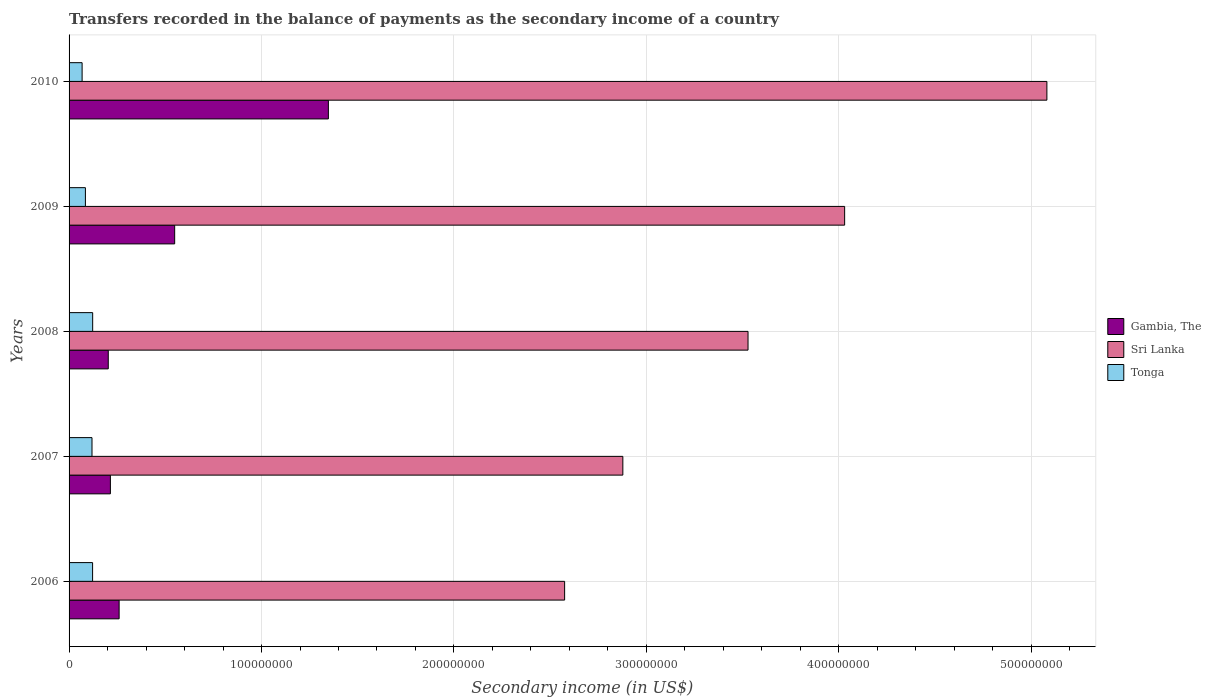How many different coloured bars are there?
Your answer should be very brief. 3. Are the number of bars per tick equal to the number of legend labels?
Offer a terse response. Yes. How many bars are there on the 3rd tick from the top?
Your answer should be very brief. 3. How many bars are there on the 1st tick from the bottom?
Your answer should be very brief. 3. What is the label of the 5th group of bars from the top?
Your response must be concise. 2006. In how many cases, is the number of bars for a given year not equal to the number of legend labels?
Your answer should be compact. 0. What is the secondary income of in Tonga in 2009?
Provide a succinct answer. 8.49e+06. Across all years, what is the maximum secondary income of in Tonga?
Offer a terse response. 1.23e+07. Across all years, what is the minimum secondary income of in Gambia, The?
Offer a terse response. 2.04e+07. In which year was the secondary income of in Tonga maximum?
Provide a short and direct response. 2008. In which year was the secondary income of in Gambia, The minimum?
Offer a terse response. 2008. What is the total secondary income of in Sri Lanka in the graph?
Provide a short and direct response. 1.81e+09. What is the difference between the secondary income of in Sri Lanka in 2009 and that in 2010?
Make the answer very short. -1.05e+08. What is the difference between the secondary income of in Gambia, The in 2006 and the secondary income of in Tonga in 2008?
Your answer should be very brief. 1.37e+07. What is the average secondary income of in Gambia, The per year?
Your answer should be compact. 5.15e+07. In the year 2006, what is the difference between the secondary income of in Tonga and secondary income of in Sri Lanka?
Provide a short and direct response. -2.45e+08. What is the ratio of the secondary income of in Tonga in 2008 to that in 2010?
Provide a succinct answer. 1.81. What is the difference between the highest and the second highest secondary income of in Sri Lanka?
Keep it short and to the point. 1.05e+08. What is the difference between the highest and the lowest secondary income of in Sri Lanka?
Keep it short and to the point. 2.51e+08. In how many years, is the secondary income of in Sri Lanka greater than the average secondary income of in Sri Lanka taken over all years?
Your answer should be compact. 2. Is the sum of the secondary income of in Gambia, The in 2007 and 2010 greater than the maximum secondary income of in Sri Lanka across all years?
Your answer should be compact. No. What does the 2nd bar from the top in 2008 represents?
Offer a terse response. Sri Lanka. What does the 3rd bar from the bottom in 2009 represents?
Provide a succinct answer. Tonga. Is it the case that in every year, the sum of the secondary income of in Gambia, The and secondary income of in Sri Lanka is greater than the secondary income of in Tonga?
Your answer should be very brief. Yes. Are all the bars in the graph horizontal?
Offer a very short reply. Yes. Where does the legend appear in the graph?
Offer a terse response. Center right. What is the title of the graph?
Your answer should be compact. Transfers recorded in the balance of payments as the secondary income of a country. What is the label or title of the X-axis?
Provide a succinct answer. Secondary income (in US$). What is the Secondary income (in US$) in Gambia, The in 2006?
Your response must be concise. 2.60e+07. What is the Secondary income (in US$) in Sri Lanka in 2006?
Your response must be concise. 2.58e+08. What is the Secondary income (in US$) in Tonga in 2006?
Make the answer very short. 1.22e+07. What is the Secondary income (in US$) in Gambia, The in 2007?
Give a very brief answer. 2.15e+07. What is the Secondary income (in US$) of Sri Lanka in 2007?
Keep it short and to the point. 2.88e+08. What is the Secondary income (in US$) in Tonga in 2007?
Your answer should be compact. 1.19e+07. What is the Secondary income (in US$) of Gambia, The in 2008?
Make the answer very short. 2.04e+07. What is the Secondary income (in US$) of Sri Lanka in 2008?
Ensure brevity in your answer.  3.53e+08. What is the Secondary income (in US$) of Tonga in 2008?
Offer a very short reply. 1.23e+07. What is the Secondary income (in US$) of Gambia, The in 2009?
Your answer should be very brief. 5.49e+07. What is the Secondary income (in US$) of Sri Lanka in 2009?
Your response must be concise. 4.03e+08. What is the Secondary income (in US$) of Tonga in 2009?
Give a very brief answer. 8.49e+06. What is the Secondary income (in US$) of Gambia, The in 2010?
Ensure brevity in your answer.  1.35e+08. What is the Secondary income (in US$) of Sri Lanka in 2010?
Offer a very short reply. 5.08e+08. What is the Secondary income (in US$) of Tonga in 2010?
Your answer should be very brief. 6.77e+06. Across all years, what is the maximum Secondary income (in US$) of Gambia, The?
Ensure brevity in your answer.  1.35e+08. Across all years, what is the maximum Secondary income (in US$) in Sri Lanka?
Give a very brief answer. 5.08e+08. Across all years, what is the maximum Secondary income (in US$) of Tonga?
Provide a succinct answer. 1.23e+07. Across all years, what is the minimum Secondary income (in US$) of Gambia, The?
Offer a terse response. 2.04e+07. Across all years, what is the minimum Secondary income (in US$) in Sri Lanka?
Your response must be concise. 2.58e+08. Across all years, what is the minimum Secondary income (in US$) of Tonga?
Your answer should be compact. 6.77e+06. What is the total Secondary income (in US$) in Gambia, The in the graph?
Keep it short and to the point. 2.57e+08. What is the total Secondary income (in US$) in Sri Lanka in the graph?
Your answer should be very brief. 1.81e+09. What is the total Secondary income (in US$) in Tonga in the graph?
Keep it short and to the point. 5.17e+07. What is the difference between the Secondary income (in US$) in Gambia, The in 2006 and that in 2007?
Offer a terse response. 4.54e+06. What is the difference between the Secondary income (in US$) of Sri Lanka in 2006 and that in 2007?
Make the answer very short. -3.02e+07. What is the difference between the Secondary income (in US$) of Tonga in 2006 and that in 2007?
Keep it short and to the point. 3.08e+05. What is the difference between the Secondary income (in US$) in Gambia, The in 2006 and that in 2008?
Make the answer very short. 5.64e+06. What is the difference between the Secondary income (in US$) of Sri Lanka in 2006 and that in 2008?
Keep it short and to the point. -9.53e+07. What is the difference between the Secondary income (in US$) of Tonga in 2006 and that in 2008?
Give a very brief answer. -4.22e+04. What is the difference between the Secondary income (in US$) of Gambia, The in 2006 and that in 2009?
Ensure brevity in your answer.  -2.89e+07. What is the difference between the Secondary income (in US$) of Sri Lanka in 2006 and that in 2009?
Your answer should be compact. -1.46e+08. What is the difference between the Secondary income (in US$) in Tonga in 2006 and that in 2009?
Keep it short and to the point. 3.73e+06. What is the difference between the Secondary income (in US$) of Gambia, The in 2006 and that in 2010?
Keep it short and to the point. -1.09e+08. What is the difference between the Secondary income (in US$) of Sri Lanka in 2006 and that in 2010?
Your response must be concise. -2.51e+08. What is the difference between the Secondary income (in US$) in Tonga in 2006 and that in 2010?
Offer a very short reply. 5.45e+06. What is the difference between the Secondary income (in US$) of Gambia, The in 2007 and that in 2008?
Provide a short and direct response. 1.10e+06. What is the difference between the Secondary income (in US$) in Sri Lanka in 2007 and that in 2008?
Provide a succinct answer. -6.50e+07. What is the difference between the Secondary income (in US$) in Tonga in 2007 and that in 2008?
Offer a very short reply. -3.50e+05. What is the difference between the Secondary income (in US$) of Gambia, The in 2007 and that in 2009?
Provide a succinct answer. -3.34e+07. What is the difference between the Secondary income (in US$) of Sri Lanka in 2007 and that in 2009?
Offer a terse response. -1.15e+08. What is the difference between the Secondary income (in US$) in Tonga in 2007 and that in 2009?
Provide a succinct answer. 3.42e+06. What is the difference between the Secondary income (in US$) in Gambia, The in 2007 and that in 2010?
Your response must be concise. -1.13e+08. What is the difference between the Secondary income (in US$) in Sri Lanka in 2007 and that in 2010?
Offer a terse response. -2.20e+08. What is the difference between the Secondary income (in US$) of Tonga in 2007 and that in 2010?
Your answer should be compact. 5.14e+06. What is the difference between the Secondary income (in US$) in Gambia, The in 2008 and that in 2009?
Your answer should be very brief. -3.45e+07. What is the difference between the Secondary income (in US$) of Sri Lanka in 2008 and that in 2009?
Keep it short and to the point. -5.02e+07. What is the difference between the Secondary income (in US$) in Tonga in 2008 and that in 2009?
Give a very brief answer. 3.77e+06. What is the difference between the Secondary income (in US$) of Gambia, The in 2008 and that in 2010?
Your response must be concise. -1.14e+08. What is the difference between the Secondary income (in US$) of Sri Lanka in 2008 and that in 2010?
Offer a very short reply. -1.55e+08. What is the difference between the Secondary income (in US$) in Tonga in 2008 and that in 2010?
Keep it short and to the point. 5.49e+06. What is the difference between the Secondary income (in US$) in Gambia, The in 2009 and that in 2010?
Provide a succinct answer. -7.99e+07. What is the difference between the Secondary income (in US$) of Sri Lanka in 2009 and that in 2010?
Keep it short and to the point. -1.05e+08. What is the difference between the Secondary income (in US$) of Tonga in 2009 and that in 2010?
Offer a very short reply. 1.72e+06. What is the difference between the Secondary income (in US$) of Gambia, The in 2006 and the Secondary income (in US$) of Sri Lanka in 2007?
Your response must be concise. -2.62e+08. What is the difference between the Secondary income (in US$) of Gambia, The in 2006 and the Secondary income (in US$) of Tonga in 2007?
Your response must be concise. 1.41e+07. What is the difference between the Secondary income (in US$) of Sri Lanka in 2006 and the Secondary income (in US$) of Tonga in 2007?
Keep it short and to the point. 2.46e+08. What is the difference between the Secondary income (in US$) in Gambia, The in 2006 and the Secondary income (in US$) in Sri Lanka in 2008?
Ensure brevity in your answer.  -3.27e+08. What is the difference between the Secondary income (in US$) of Gambia, The in 2006 and the Secondary income (in US$) of Tonga in 2008?
Keep it short and to the point. 1.37e+07. What is the difference between the Secondary income (in US$) of Sri Lanka in 2006 and the Secondary income (in US$) of Tonga in 2008?
Your response must be concise. 2.45e+08. What is the difference between the Secondary income (in US$) in Gambia, The in 2006 and the Secondary income (in US$) in Sri Lanka in 2009?
Your response must be concise. -3.77e+08. What is the difference between the Secondary income (in US$) of Gambia, The in 2006 and the Secondary income (in US$) of Tonga in 2009?
Your answer should be very brief. 1.75e+07. What is the difference between the Secondary income (in US$) of Sri Lanka in 2006 and the Secondary income (in US$) of Tonga in 2009?
Give a very brief answer. 2.49e+08. What is the difference between the Secondary income (in US$) of Gambia, The in 2006 and the Secondary income (in US$) of Sri Lanka in 2010?
Ensure brevity in your answer.  -4.82e+08. What is the difference between the Secondary income (in US$) of Gambia, The in 2006 and the Secondary income (in US$) of Tonga in 2010?
Make the answer very short. 1.92e+07. What is the difference between the Secondary income (in US$) in Sri Lanka in 2006 and the Secondary income (in US$) in Tonga in 2010?
Ensure brevity in your answer.  2.51e+08. What is the difference between the Secondary income (in US$) in Gambia, The in 2007 and the Secondary income (in US$) in Sri Lanka in 2008?
Make the answer very short. -3.31e+08. What is the difference between the Secondary income (in US$) of Gambia, The in 2007 and the Secondary income (in US$) of Tonga in 2008?
Your answer should be compact. 9.21e+06. What is the difference between the Secondary income (in US$) in Sri Lanka in 2007 and the Secondary income (in US$) in Tonga in 2008?
Offer a very short reply. 2.75e+08. What is the difference between the Secondary income (in US$) of Gambia, The in 2007 and the Secondary income (in US$) of Sri Lanka in 2009?
Offer a very short reply. -3.82e+08. What is the difference between the Secondary income (in US$) in Gambia, The in 2007 and the Secondary income (in US$) in Tonga in 2009?
Your response must be concise. 1.30e+07. What is the difference between the Secondary income (in US$) in Sri Lanka in 2007 and the Secondary income (in US$) in Tonga in 2009?
Give a very brief answer. 2.79e+08. What is the difference between the Secondary income (in US$) of Gambia, The in 2007 and the Secondary income (in US$) of Sri Lanka in 2010?
Provide a succinct answer. -4.87e+08. What is the difference between the Secondary income (in US$) of Gambia, The in 2007 and the Secondary income (in US$) of Tonga in 2010?
Provide a succinct answer. 1.47e+07. What is the difference between the Secondary income (in US$) of Sri Lanka in 2007 and the Secondary income (in US$) of Tonga in 2010?
Your answer should be very brief. 2.81e+08. What is the difference between the Secondary income (in US$) of Gambia, The in 2008 and the Secondary income (in US$) of Sri Lanka in 2009?
Ensure brevity in your answer.  -3.83e+08. What is the difference between the Secondary income (in US$) of Gambia, The in 2008 and the Secondary income (in US$) of Tonga in 2009?
Make the answer very short. 1.19e+07. What is the difference between the Secondary income (in US$) of Sri Lanka in 2008 and the Secondary income (in US$) of Tonga in 2009?
Keep it short and to the point. 3.44e+08. What is the difference between the Secondary income (in US$) in Gambia, The in 2008 and the Secondary income (in US$) in Sri Lanka in 2010?
Make the answer very short. -4.88e+08. What is the difference between the Secondary income (in US$) in Gambia, The in 2008 and the Secondary income (in US$) in Tonga in 2010?
Keep it short and to the point. 1.36e+07. What is the difference between the Secondary income (in US$) of Sri Lanka in 2008 and the Secondary income (in US$) of Tonga in 2010?
Offer a terse response. 3.46e+08. What is the difference between the Secondary income (in US$) in Gambia, The in 2009 and the Secondary income (in US$) in Sri Lanka in 2010?
Offer a terse response. -4.53e+08. What is the difference between the Secondary income (in US$) in Gambia, The in 2009 and the Secondary income (in US$) in Tonga in 2010?
Make the answer very short. 4.81e+07. What is the difference between the Secondary income (in US$) in Sri Lanka in 2009 and the Secondary income (in US$) in Tonga in 2010?
Offer a very short reply. 3.96e+08. What is the average Secondary income (in US$) of Gambia, The per year?
Your response must be concise. 5.15e+07. What is the average Secondary income (in US$) in Sri Lanka per year?
Provide a succinct answer. 3.62e+08. What is the average Secondary income (in US$) of Tonga per year?
Provide a succinct answer. 1.03e+07. In the year 2006, what is the difference between the Secondary income (in US$) in Gambia, The and Secondary income (in US$) in Sri Lanka?
Give a very brief answer. -2.31e+08. In the year 2006, what is the difference between the Secondary income (in US$) in Gambia, The and Secondary income (in US$) in Tonga?
Your response must be concise. 1.38e+07. In the year 2006, what is the difference between the Secondary income (in US$) in Sri Lanka and Secondary income (in US$) in Tonga?
Ensure brevity in your answer.  2.45e+08. In the year 2007, what is the difference between the Secondary income (in US$) of Gambia, The and Secondary income (in US$) of Sri Lanka?
Offer a very short reply. -2.66e+08. In the year 2007, what is the difference between the Secondary income (in US$) of Gambia, The and Secondary income (in US$) of Tonga?
Provide a succinct answer. 9.56e+06. In the year 2007, what is the difference between the Secondary income (in US$) in Sri Lanka and Secondary income (in US$) in Tonga?
Your response must be concise. 2.76e+08. In the year 2008, what is the difference between the Secondary income (in US$) in Gambia, The and Secondary income (in US$) in Sri Lanka?
Give a very brief answer. -3.32e+08. In the year 2008, what is the difference between the Secondary income (in US$) in Gambia, The and Secondary income (in US$) in Tonga?
Provide a short and direct response. 8.11e+06. In the year 2008, what is the difference between the Secondary income (in US$) of Sri Lanka and Secondary income (in US$) of Tonga?
Offer a very short reply. 3.41e+08. In the year 2009, what is the difference between the Secondary income (in US$) of Gambia, The and Secondary income (in US$) of Sri Lanka?
Your answer should be very brief. -3.48e+08. In the year 2009, what is the difference between the Secondary income (in US$) of Gambia, The and Secondary income (in US$) of Tonga?
Offer a terse response. 4.64e+07. In the year 2009, what is the difference between the Secondary income (in US$) of Sri Lanka and Secondary income (in US$) of Tonga?
Give a very brief answer. 3.95e+08. In the year 2010, what is the difference between the Secondary income (in US$) of Gambia, The and Secondary income (in US$) of Sri Lanka?
Keep it short and to the point. -3.73e+08. In the year 2010, what is the difference between the Secondary income (in US$) in Gambia, The and Secondary income (in US$) in Tonga?
Give a very brief answer. 1.28e+08. In the year 2010, what is the difference between the Secondary income (in US$) of Sri Lanka and Secondary income (in US$) of Tonga?
Provide a short and direct response. 5.01e+08. What is the ratio of the Secondary income (in US$) of Gambia, The in 2006 to that in 2007?
Your answer should be compact. 1.21. What is the ratio of the Secondary income (in US$) in Sri Lanka in 2006 to that in 2007?
Provide a short and direct response. 0.89. What is the ratio of the Secondary income (in US$) of Tonga in 2006 to that in 2007?
Offer a terse response. 1.03. What is the ratio of the Secondary income (in US$) in Gambia, The in 2006 to that in 2008?
Offer a very short reply. 1.28. What is the ratio of the Secondary income (in US$) in Sri Lanka in 2006 to that in 2008?
Offer a very short reply. 0.73. What is the ratio of the Secondary income (in US$) of Gambia, The in 2006 to that in 2009?
Give a very brief answer. 0.47. What is the ratio of the Secondary income (in US$) of Sri Lanka in 2006 to that in 2009?
Make the answer very short. 0.64. What is the ratio of the Secondary income (in US$) of Tonga in 2006 to that in 2009?
Make the answer very short. 1.44. What is the ratio of the Secondary income (in US$) in Gambia, The in 2006 to that in 2010?
Offer a very short reply. 0.19. What is the ratio of the Secondary income (in US$) of Sri Lanka in 2006 to that in 2010?
Provide a short and direct response. 0.51. What is the ratio of the Secondary income (in US$) in Tonga in 2006 to that in 2010?
Provide a succinct answer. 1.8. What is the ratio of the Secondary income (in US$) in Gambia, The in 2007 to that in 2008?
Your answer should be very brief. 1.05. What is the ratio of the Secondary income (in US$) in Sri Lanka in 2007 to that in 2008?
Make the answer very short. 0.82. What is the ratio of the Secondary income (in US$) of Tonga in 2007 to that in 2008?
Keep it short and to the point. 0.97. What is the ratio of the Secondary income (in US$) of Gambia, The in 2007 to that in 2009?
Provide a short and direct response. 0.39. What is the ratio of the Secondary income (in US$) in Sri Lanka in 2007 to that in 2009?
Offer a terse response. 0.71. What is the ratio of the Secondary income (in US$) of Tonga in 2007 to that in 2009?
Your answer should be very brief. 1.4. What is the ratio of the Secondary income (in US$) of Gambia, The in 2007 to that in 2010?
Your answer should be very brief. 0.16. What is the ratio of the Secondary income (in US$) in Sri Lanka in 2007 to that in 2010?
Provide a short and direct response. 0.57. What is the ratio of the Secondary income (in US$) of Tonga in 2007 to that in 2010?
Your answer should be very brief. 1.76. What is the ratio of the Secondary income (in US$) in Gambia, The in 2008 to that in 2009?
Give a very brief answer. 0.37. What is the ratio of the Secondary income (in US$) of Sri Lanka in 2008 to that in 2009?
Ensure brevity in your answer.  0.88. What is the ratio of the Secondary income (in US$) of Tonga in 2008 to that in 2009?
Ensure brevity in your answer.  1.44. What is the ratio of the Secondary income (in US$) in Gambia, The in 2008 to that in 2010?
Provide a succinct answer. 0.15. What is the ratio of the Secondary income (in US$) of Sri Lanka in 2008 to that in 2010?
Offer a very short reply. 0.69. What is the ratio of the Secondary income (in US$) in Tonga in 2008 to that in 2010?
Your response must be concise. 1.81. What is the ratio of the Secondary income (in US$) of Gambia, The in 2009 to that in 2010?
Offer a terse response. 0.41. What is the ratio of the Secondary income (in US$) in Sri Lanka in 2009 to that in 2010?
Your answer should be compact. 0.79. What is the ratio of the Secondary income (in US$) in Tonga in 2009 to that in 2010?
Offer a very short reply. 1.25. What is the difference between the highest and the second highest Secondary income (in US$) of Gambia, The?
Your answer should be compact. 7.99e+07. What is the difference between the highest and the second highest Secondary income (in US$) in Sri Lanka?
Your answer should be compact. 1.05e+08. What is the difference between the highest and the second highest Secondary income (in US$) in Tonga?
Give a very brief answer. 4.22e+04. What is the difference between the highest and the lowest Secondary income (in US$) in Gambia, The?
Your answer should be compact. 1.14e+08. What is the difference between the highest and the lowest Secondary income (in US$) of Sri Lanka?
Provide a succinct answer. 2.51e+08. What is the difference between the highest and the lowest Secondary income (in US$) in Tonga?
Give a very brief answer. 5.49e+06. 